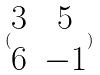<formula> <loc_0><loc_0><loc_500><loc_500>( \begin{matrix} 3 & 5 \\ 6 & - 1 \end{matrix} )</formula> 